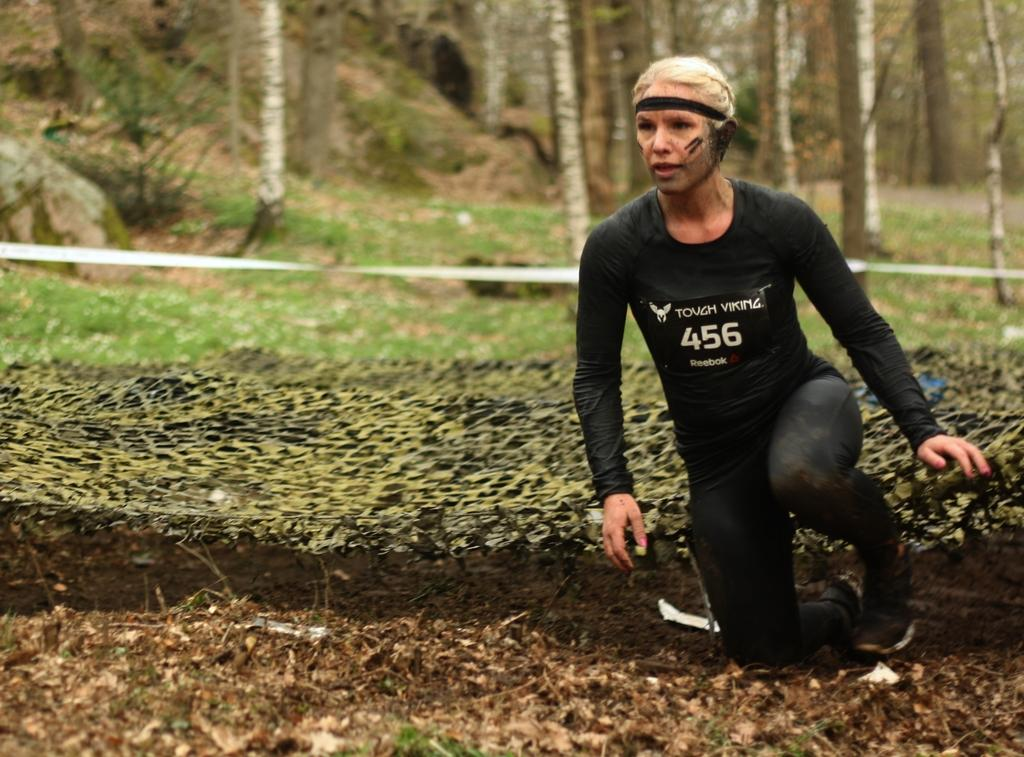What is present in the image? There is a person in the image, along with objects on the ground, grass, plants, tree trunks, and a white-colored object. Can you describe the person in the image? The facts provided do not give specific details about the person's appearance or clothing. What type of objects are on the ground in the image? The facts provided do not specify the type of objects on the ground. What is the color of the grass in the image? The grass is visible in the image, but the facts provided do not specify its color. What kind of plants are in the image? The facts provided do not specify the type of plants in the image. What is the white-colored object in the image? The facts provided do not specify the nature or purpose of the white-colored object. How does the person in the image use paste to fix the brake? There is no mention of paste or a brake in the image, so it is not possible to answer this question. 